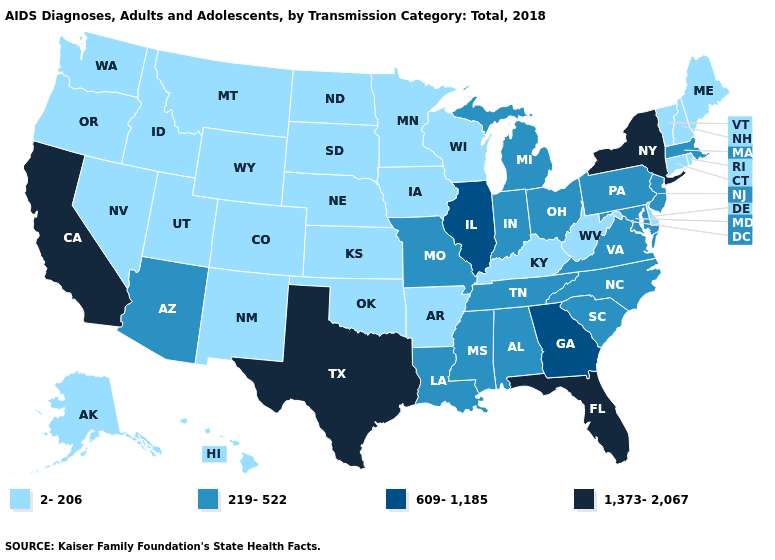Does California have the highest value in the West?
Short answer required. Yes. Which states have the highest value in the USA?
Give a very brief answer. California, Florida, New York, Texas. What is the value of Georgia?
Short answer required. 609-1,185. Among the states that border Kansas , which have the highest value?
Short answer required. Missouri. What is the value of South Carolina?
Quick response, please. 219-522. Name the states that have a value in the range 1,373-2,067?
Answer briefly. California, Florida, New York, Texas. Which states have the lowest value in the USA?
Quick response, please. Alaska, Arkansas, Colorado, Connecticut, Delaware, Hawaii, Idaho, Iowa, Kansas, Kentucky, Maine, Minnesota, Montana, Nebraska, Nevada, New Hampshire, New Mexico, North Dakota, Oklahoma, Oregon, Rhode Island, South Dakota, Utah, Vermont, Washington, West Virginia, Wisconsin, Wyoming. Which states have the lowest value in the West?
Write a very short answer. Alaska, Colorado, Hawaii, Idaho, Montana, Nevada, New Mexico, Oregon, Utah, Washington, Wyoming. Does Wisconsin have the lowest value in the MidWest?
Keep it brief. Yes. What is the value of Michigan?
Be succinct. 219-522. What is the value of Arkansas?
Write a very short answer. 2-206. What is the highest value in the USA?
Answer briefly. 1,373-2,067. Which states have the highest value in the USA?
Short answer required. California, Florida, New York, Texas. Name the states that have a value in the range 219-522?
Short answer required. Alabama, Arizona, Indiana, Louisiana, Maryland, Massachusetts, Michigan, Mississippi, Missouri, New Jersey, North Carolina, Ohio, Pennsylvania, South Carolina, Tennessee, Virginia. 